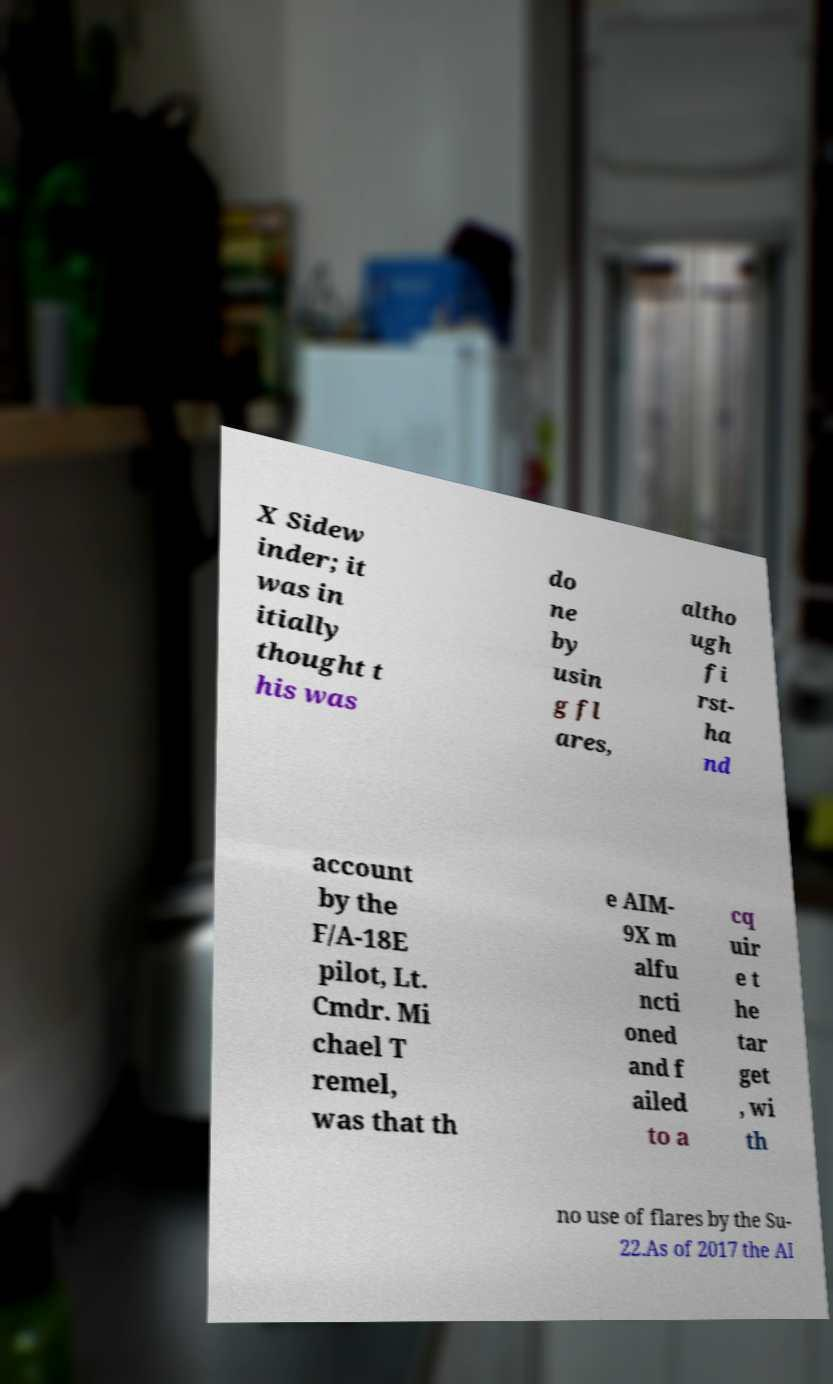Can you accurately transcribe the text from the provided image for me? X Sidew inder; it was in itially thought t his was do ne by usin g fl ares, altho ugh fi rst- ha nd account by the F/A-18E pilot, Lt. Cmdr. Mi chael T remel, was that th e AIM- 9X m alfu ncti oned and f ailed to a cq uir e t he tar get , wi th no use of flares by the Su- 22.As of 2017 the AI 